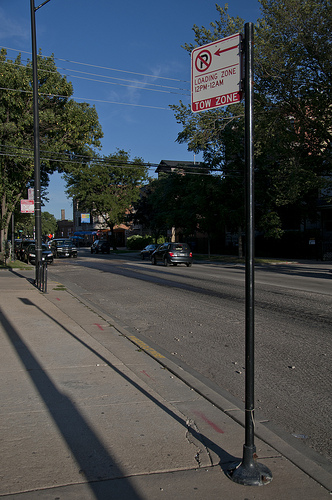Are there any traffic signs visible in the photo, and if so, what do they indicate? Yes, there is a traffic sign visible. It's a 'No Parking' sign indicating a tow-away zone with restrictions on parking during specific days and times. Can you tell me the time of day it is in the image based on the shadows? Considering the length and direction of the shadows, it appears to be late afternoon. 